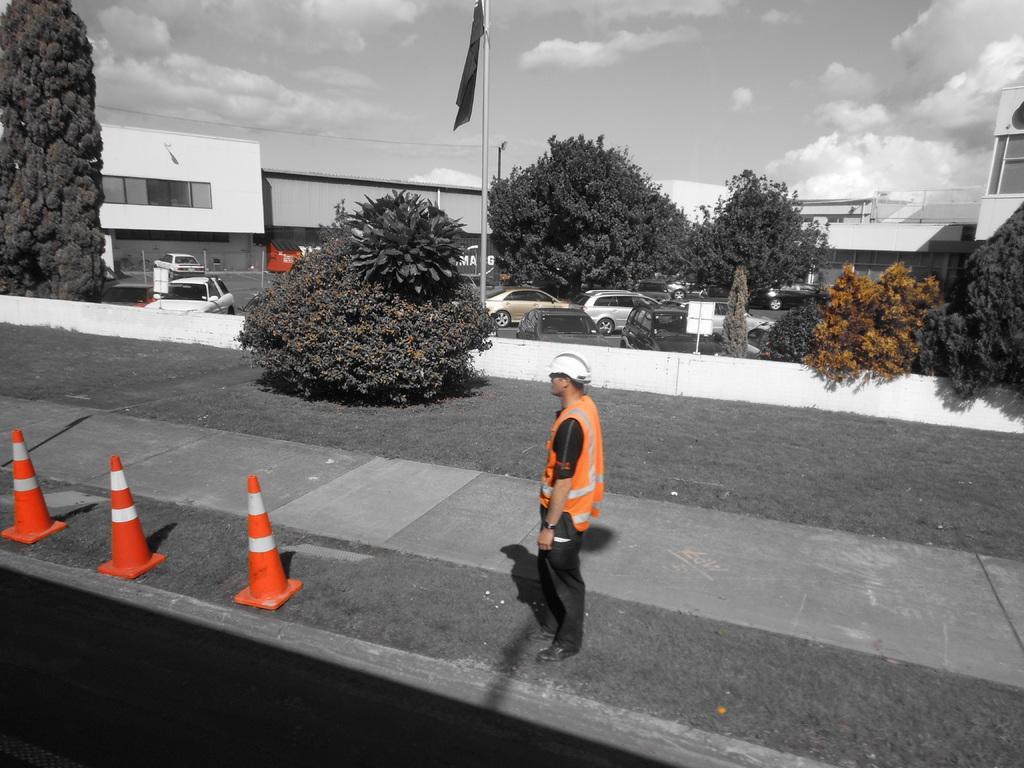Please provide a concise description of this image. In the image we can see a person standing, wearing clothes, shoes and a helmet. These are the road cones, tree, vehicles, building, pole, flag and a cloudy sky. 